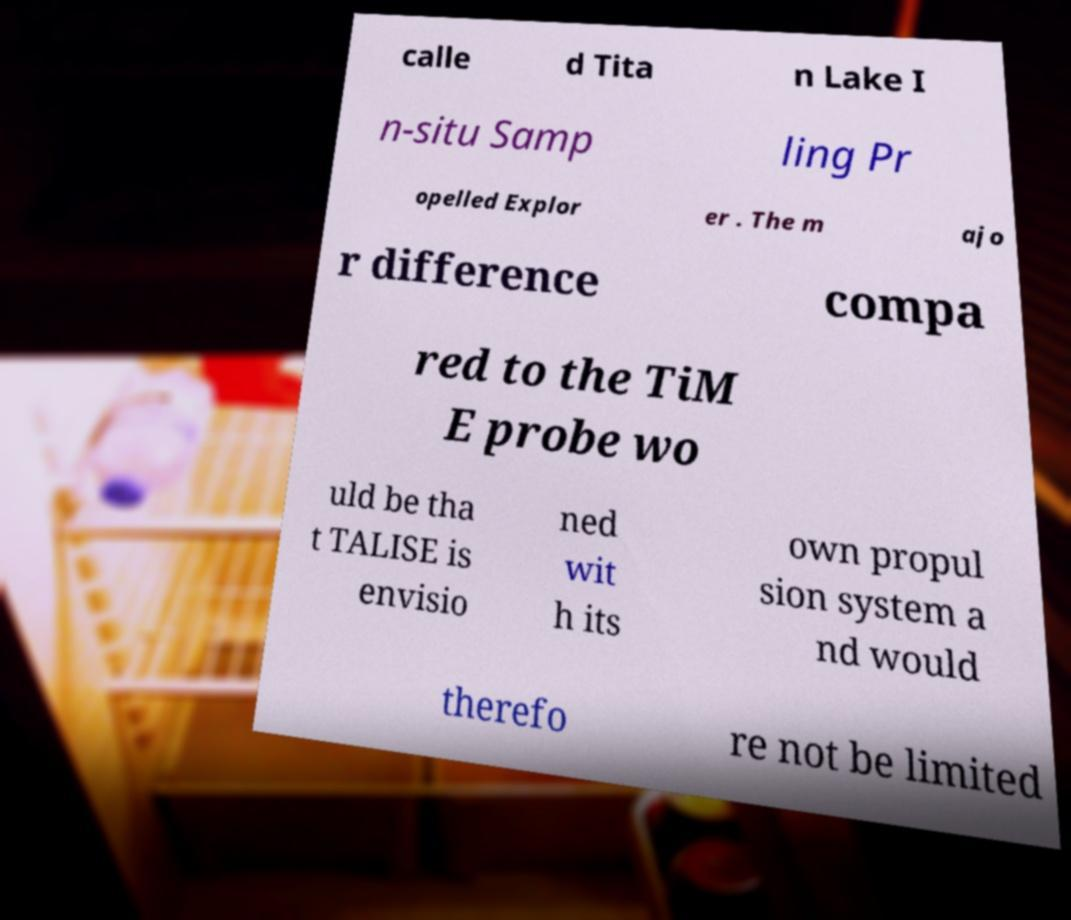Could you assist in decoding the text presented in this image and type it out clearly? calle d Tita n Lake I n-situ Samp ling Pr opelled Explor er . The m ajo r difference compa red to the TiM E probe wo uld be tha t TALISE is envisio ned wit h its own propul sion system a nd would therefo re not be limited 